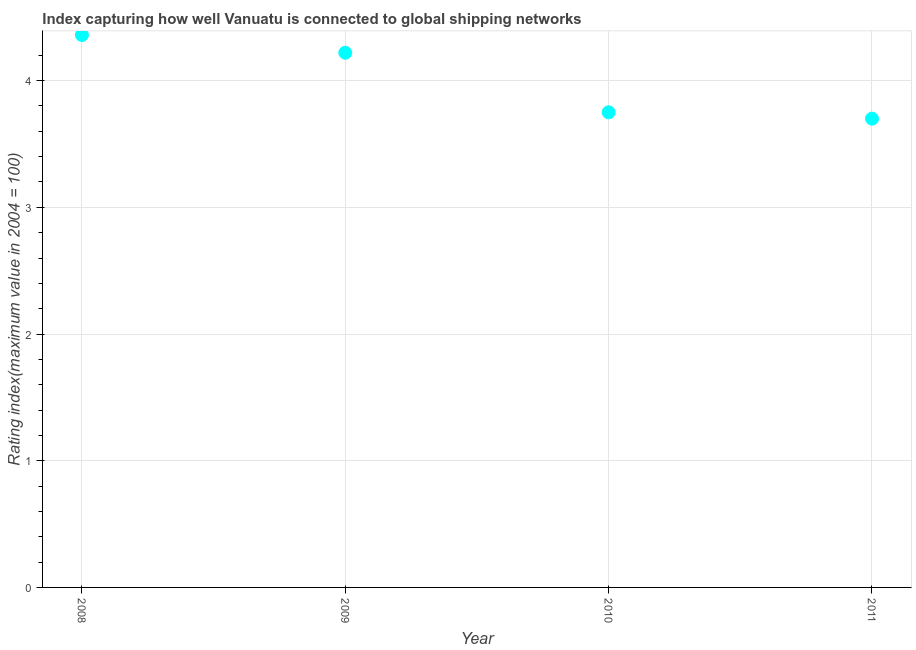What is the liner shipping connectivity index in 2009?
Offer a very short reply. 4.22. Across all years, what is the maximum liner shipping connectivity index?
Give a very brief answer. 4.36. In which year was the liner shipping connectivity index minimum?
Offer a very short reply. 2011. What is the sum of the liner shipping connectivity index?
Provide a short and direct response. 16.03. What is the difference between the liner shipping connectivity index in 2010 and 2011?
Provide a succinct answer. 0.05. What is the average liner shipping connectivity index per year?
Provide a succinct answer. 4.01. What is the median liner shipping connectivity index?
Make the answer very short. 3.98. In how many years, is the liner shipping connectivity index greater than 1.2 ?
Give a very brief answer. 4. Do a majority of the years between 2010 and 2008 (inclusive) have liner shipping connectivity index greater than 1.2 ?
Provide a succinct answer. No. What is the ratio of the liner shipping connectivity index in 2008 to that in 2011?
Your answer should be compact. 1.18. What is the difference between the highest and the second highest liner shipping connectivity index?
Offer a very short reply. 0.14. Is the sum of the liner shipping connectivity index in 2010 and 2011 greater than the maximum liner shipping connectivity index across all years?
Ensure brevity in your answer.  Yes. What is the difference between the highest and the lowest liner shipping connectivity index?
Offer a terse response. 0.66. How many years are there in the graph?
Offer a very short reply. 4. What is the difference between two consecutive major ticks on the Y-axis?
Make the answer very short. 1. Are the values on the major ticks of Y-axis written in scientific E-notation?
Keep it short and to the point. No. Does the graph contain grids?
Provide a short and direct response. Yes. What is the title of the graph?
Make the answer very short. Index capturing how well Vanuatu is connected to global shipping networks. What is the label or title of the X-axis?
Keep it short and to the point. Year. What is the label or title of the Y-axis?
Offer a terse response. Rating index(maximum value in 2004 = 100). What is the Rating index(maximum value in 2004 = 100) in 2008?
Ensure brevity in your answer.  4.36. What is the Rating index(maximum value in 2004 = 100) in 2009?
Ensure brevity in your answer.  4.22. What is the Rating index(maximum value in 2004 = 100) in 2010?
Your answer should be very brief. 3.75. What is the difference between the Rating index(maximum value in 2004 = 100) in 2008 and 2009?
Your answer should be compact. 0.14. What is the difference between the Rating index(maximum value in 2004 = 100) in 2008 and 2010?
Make the answer very short. 0.61. What is the difference between the Rating index(maximum value in 2004 = 100) in 2008 and 2011?
Your answer should be very brief. 0.66. What is the difference between the Rating index(maximum value in 2004 = 100) in 2009 and 2010?
Provide a succinct answer. 0.47. What is the difference between the Rating index(maximum value in 2004 = 100) in 2009 and 2011?
Provide a short and direct response. 0.52. What is the difference between the Rating index(maximum value in 2004 = 100) in 2010 and 2011?
Give a very brief answer. 0.05. What is the ratio of the Rating index(maximum value in 2004 = 100) in 2008 to that in 2009?
Make the answer very short. 1.03. What is the ratio of the Rating index(maximum value in 2004 = 100) in 2008 to that in 2010?
Make the answer very short. 1.16. What is the ratio of the Rating index(maximum value in 2004 = 100) in 2008 to that in 2011?
Offer a very short reply. 1.18. What is the ratio of the Rating index(maximum value in 2004 = 100) in 2009 to that in 2010?
Give a very brief answer. 1.12. What is the ratio of the Rating index(maximum value in 2004 = 100) in 2009 to that in 2011?
Give a very brief answer. 1.14. What is the ratio of the Rating index(maximum value in 2004 = 100) in 2010 to that in 2011?
Ensure brevity in your answer.  1.01. 